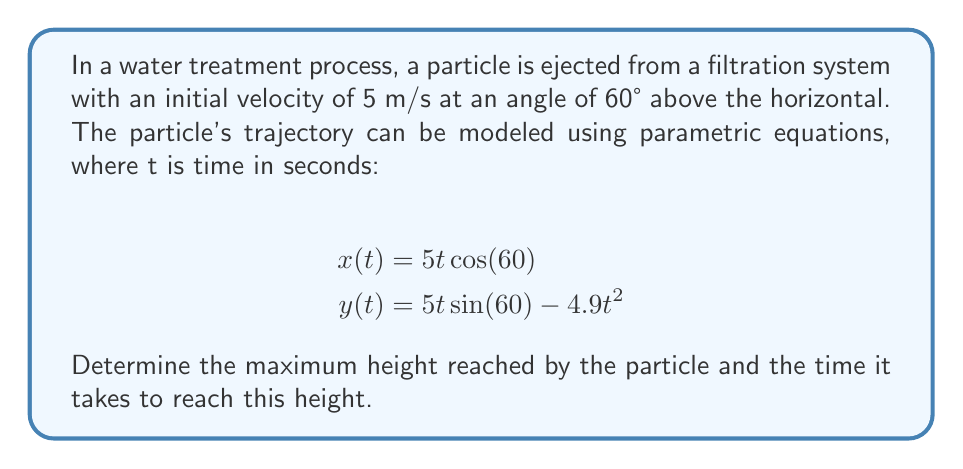Solve this math problem. To solve this problem, we'll follow these steps:

1) The maximum height occurs when the vertical velocity is zero. We can find this by taking the derivative of y(t) with respect to t and setting it equal to zero.

2) The vertical component of the velocity is given by:
   $$\frac{dy}{dt} = 5\sin(60°) - 9.8t$$

3) Set this equal to zero and solve for t:
   $$5\sin(60°) - 9.8t = 0$$
   $$5 \cdot \frac{\sqrt{3}}{2} - 9.8t = 0$$
   $$\frac{5\sqrt{3}}{2} = 9.8t$$
   $$t = \frac{5\sqrt{3}}{2 \cdot 9.8} \approx 0.44 \text{ seconds}$$

4) Now that we know the time at which the maximum height is reached, we can substitute this back into the equation for y(t) to find the maximum height:

   $$y(0.44) = 5(0.44)\sin(60°) - 4.9(0.44)^2$$
   $$= 5(0.44) \cdot \frac{\sqrt{3}}{2} - 4.9(0.44)^2$$
   $$= 1.91 - 0.95$$
   $$= 0.96 \text{ meters}$$

Therefore, the particle reaches a maximum height of approximately 0.96 meters after about 0.44 seconds.
Answer: Maximum height: 0.96 meters
Time to reach maximum height: 0.44 seconds 